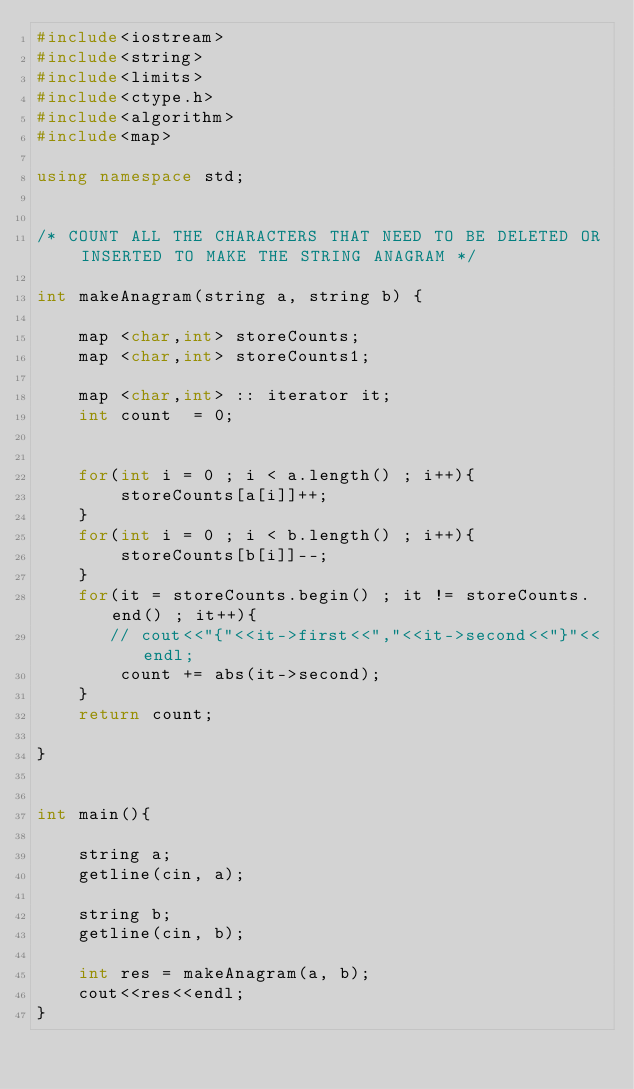Convert code to text. <code><loc_0><loc_0><loc_500><loc_500><_C++_>#include<iostream>
#include<string>
#include<limits>
#include<ctype.h>
#include<algorithm>
#include<map>

using namespace std;


/* COUNT ALL THE CHARACTERS THAT NEED TO BE DELETED OR INSERTED TO MAKE THE STRING ANAGRAM */

int makeAnagram(string a, string b) {

    map <char,int> storeCounts;
    map <char,int> storeCounts1;

    map <char,int> :: iterator it;
    int count  = 0;


    for(int i = 0 ; i < a.length() ; i++){
        storeCounts[a[i]]++;
    }
    for(int i = 0 ; i < b.length() ; i++){
        storeCounts[b[i]]--;
    }
    for(it = storeCounts.begin() ; it != storeCounts.end() ; it++){
       // cout<<"{"<<it->first<<","<<it->second<<"}"<<endl;
        count += abs(it->second);  
    }
    return count;

}


int main(){
    
    string a;
    getline(cin, a);

    string b;
    getline(cin, b);

    int res = makeAnagram(a, b);
    cout<<res<<endl;
}
</code> 